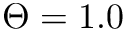Convert formula to latex. <formula><loc_0><loc_0><loc_500><loc_500>\Theta = 1 . 0</formula> 